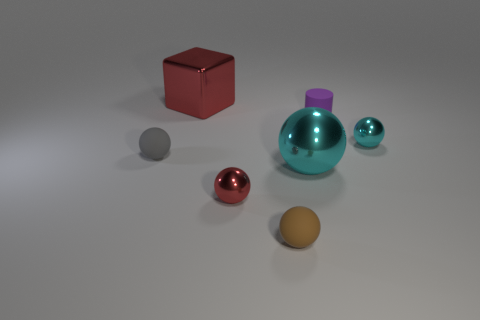Subtract all small spheres. How many spheres are left? 1 Subtract all brown cylinders. How many cyan spheres are left? 2 Subtract all red spheres. How many spheres are left? 4 Add 1 big cubes. How many objects exist? 8 Subtract 3 balls. How many balls are left? 2 Subtract all cubes. How many objects are left? 6 Add 2 purple cylinders. How many purple cylinders exist? 3 Subtract 0 blue spheres. How many objects are left? 7 Subtract all red cylinders. Subtract all red cubes. How many cylinders are left? 1 Subtract all small rubber things. Subtract all big cyan shiny things. How many objects are left? 3 